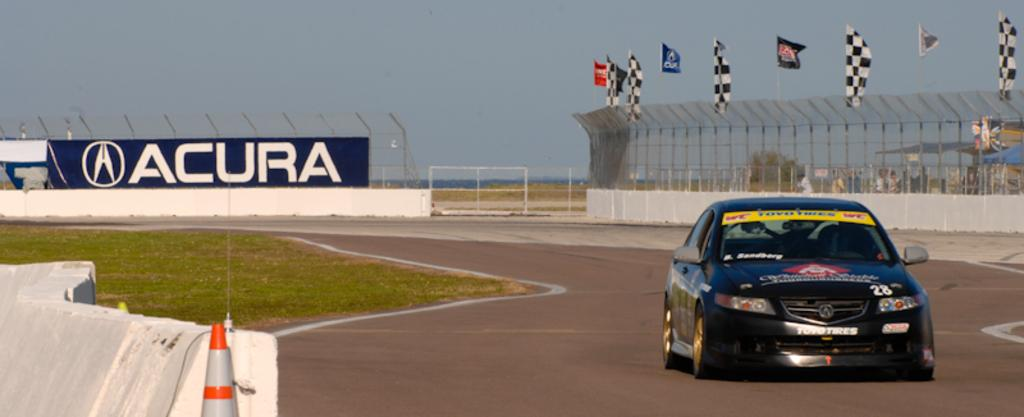What is the main subject of the image? There is a car on the road in the image. What type of vegetation can be seen in the image? Grass is visible in the image. What safety feature is present in the image? A traffic cone is present in the image. What type of barriers are in the image? There are fences in the image. What type of signage is present in the image? There are posters and flags in the image. What other objects can be seen in the image? There are other objects in the image, but their specific details are not mentioned in the facts. What can be seen in the background of the image? There is a group of people, a tree, and the sky visible in the background of the image. What type of arch can be seen in the image? There is no arch present in the image. How does the car shake while driving in the image? The car does not shake while driving in the image; it is stationary. What type of advertisement is being displayed on the car in the image? There is no information about any advertisement on the car in the image. 